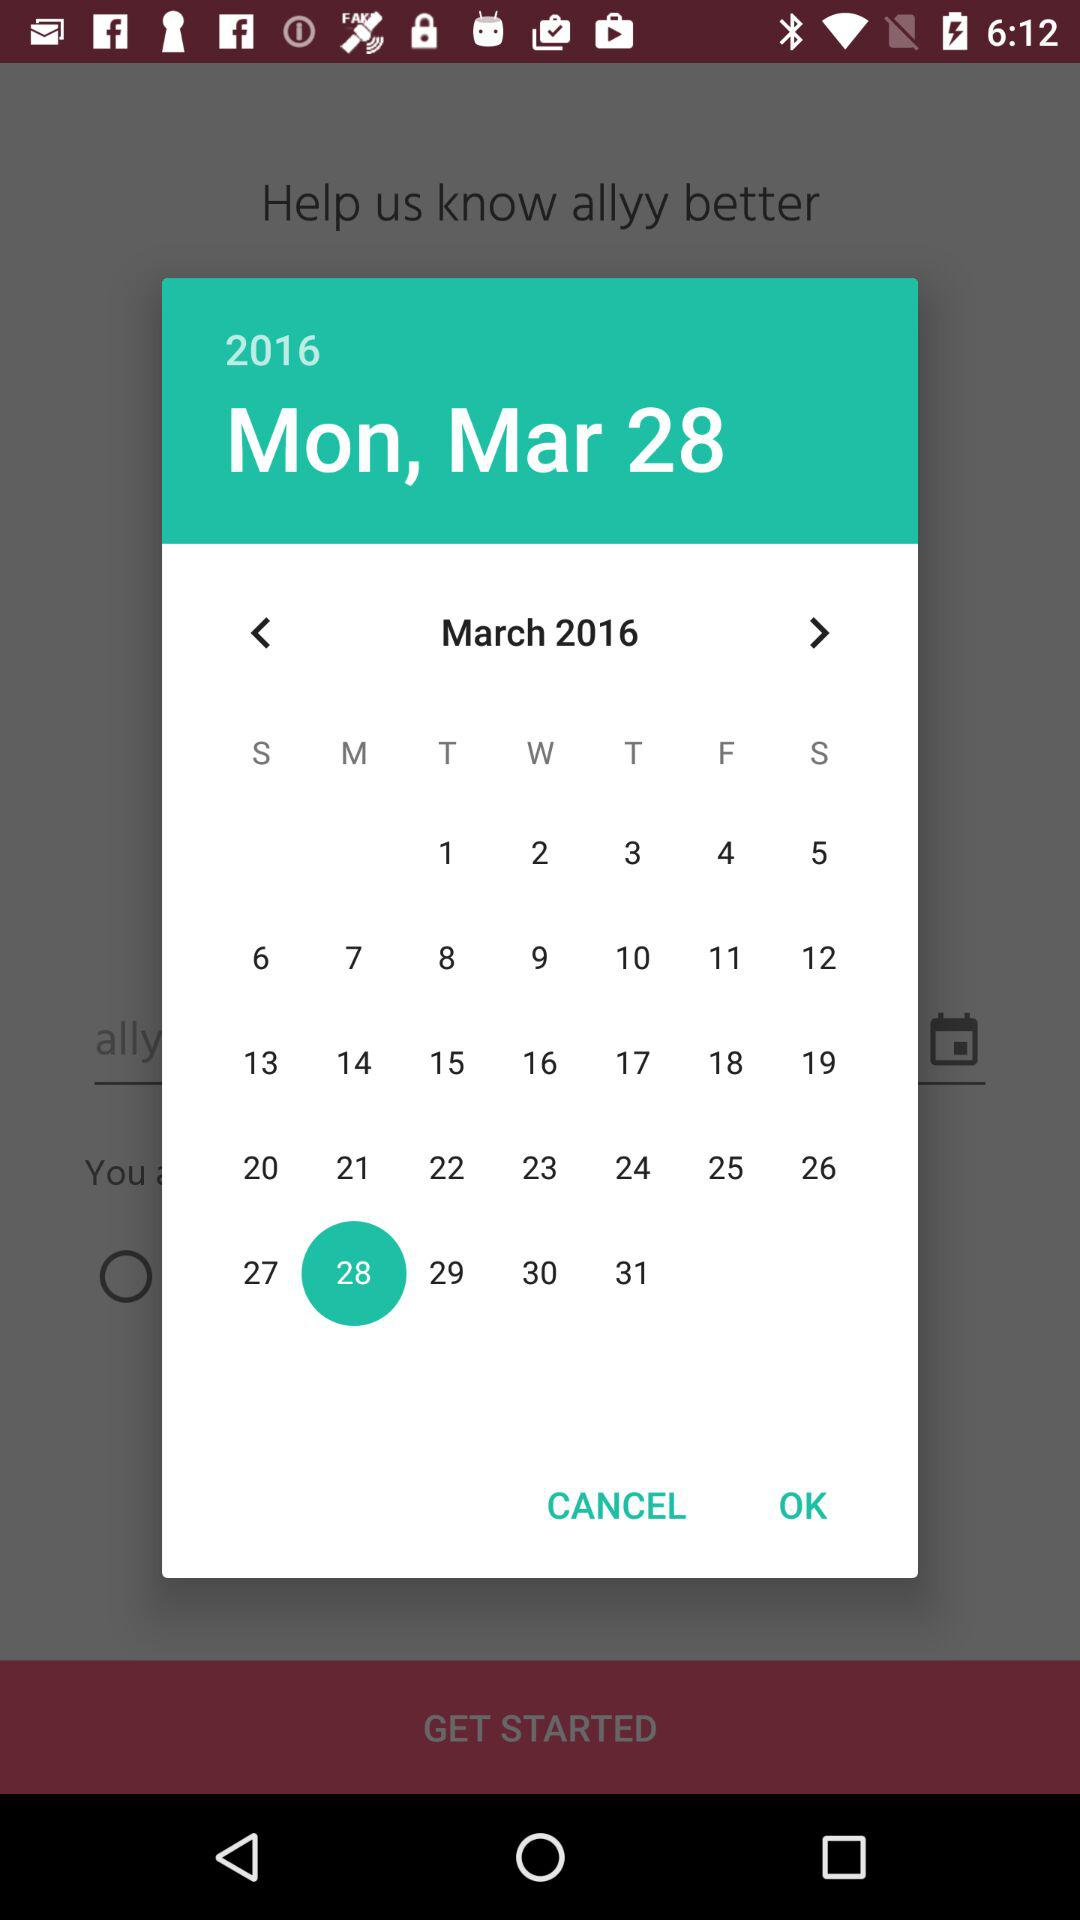What date is selected? The selected date is Monday, March 28, 2016. 